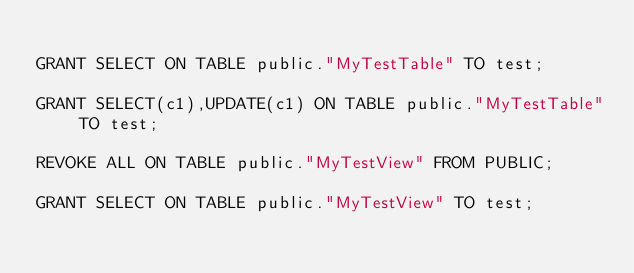Convert code to text. <code><loc_0><loc_0><loc_500><loc_500><_SQL_>
GRANT SELECT ON TABLE public."MyTestTable" TO test;

GRANT SELECT(c1),UPDATE(c1) ON TABLE public."MyTestTable" TO test;

REVOKE ALL ON TABLE public."MyTestView" FROM PUBLIC;

GRANT SELECT ON TABLE public."MyTestView" TO test;</code> 